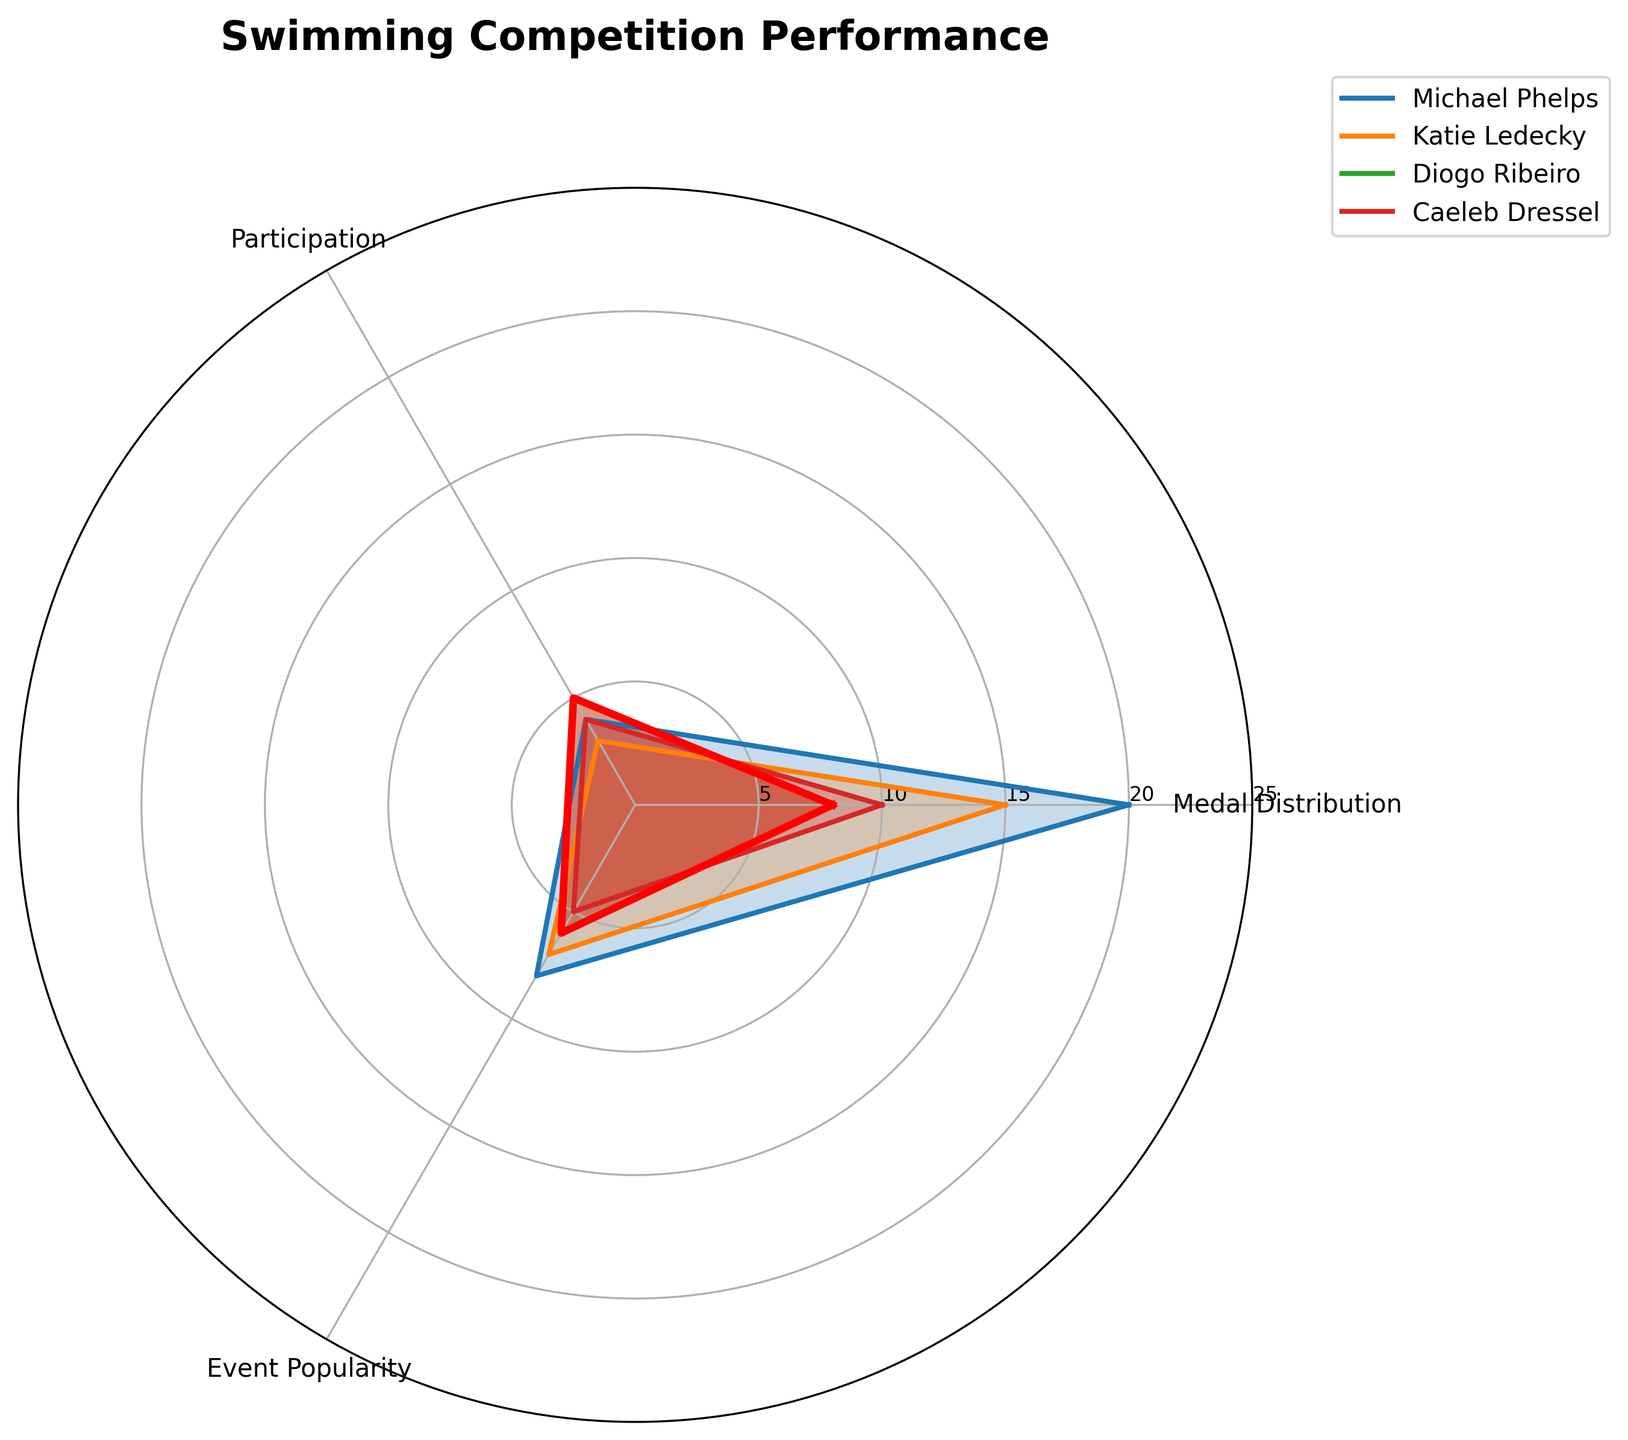what is the title of the figure? Look at the top section of the radar plot where the title is positioned prominently. The title is "Swimming Competition Performance."
Answer: Swimming Competition Performance how many categories are used in the radar plot? Count the number of labels around the radar plot which correspond to the categories being compared. There are three categories: 'Medal Distribution', 'Participation', and 'Event Popularity'.
Answer: 3 which athlete has the highest 'Medal Distribution'? Examine the 'Medal Distribution' axis and find the athlete whose plot line extends the furthest along that axis. Michael Phelps has the highest value in the 'Medal Distribution' category with a value of 20.
Answer: Michael Phelps compare Diogo Ribeiro’s 'Participation' and 'Event Popularity' values - which one is higher? Check where Diogo Ribeiro’s plot intersects the 'Participation' and 'Event Popularity' axes. Diogo Ribeiro has a 'Participation' value of 5 and an 'Event Popularity' value of 6. Hence, 'Event Popularity' is higher.
Answer: Event Popularity how do Michael Phelps and Katie Ledecky compare in terms of 'Medal Distribution'? Look at the 'Medal Distribution' axis for both athletes. Michael Phelps has a 'Medal Distribution' value of 20, and Katie Ledecky has a value of 15. Therefore, Michael Phelps has a higher value in terms of 'Medal Distribution'.
Answer: Michael Phelps what is the average 'Event Popularity' value for all athletes? Sum the 'Event Popularity' values for all athletes and divide by the number of athletes. The values are 8 (Michael Phelps), 7 (Katie Ledecky), 6 (Diogo Ribeiro), and 5 (Caeleb Dressel). The average is (8 + 7 + 6 + 5) / 4 = 6.5.
Answer: 6.5 which athlete’s performance is highlighted in a different color and with thicker lines? Notice the plot that uses thicker lines and a different color enhancing the visibility of one athlete. Diogo Ribeiro’s performance is highlighted in red with thicker lines.
Answer: Diogo Ribeiro in the category 'Participation', which athlete has a value equal to 4? Inspect the 'Participation' axis to identify which athletes have a value of 4. Both Michael Phelps and Caeleb Dressel have a 'Participation' value of 4.
Answer: Michael Phelps, Caeleb Dressel what is the median 'Medal Distribution' value of all athletes? Arrange the 'Medal Distribution' values in ascending order (8, 10, 15, 20) and find the middle value(s). The median is the average of the two middle values (10 + 15) / 2, which is 12.5.
Answer: 12.5 